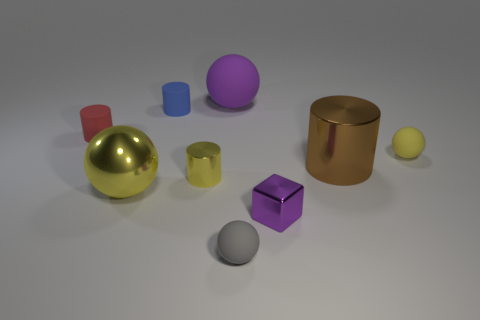Subtract 1 cylinders. How many cylinders are left? 3 Add 1 big purple spheres. How many objects exist? 10 Subtract all spheres. How many objects are left? 5 Add 7 metallic blocks. How many metallic blocks exist? 8 Subtract 1 red cylinders. How many objects are left? 8 Subtract all cyan rubber objects. Subtract all tiny red things. How many objects are left? 8 Add 5 yellow matte things. How many yellow matte things are left? 6 